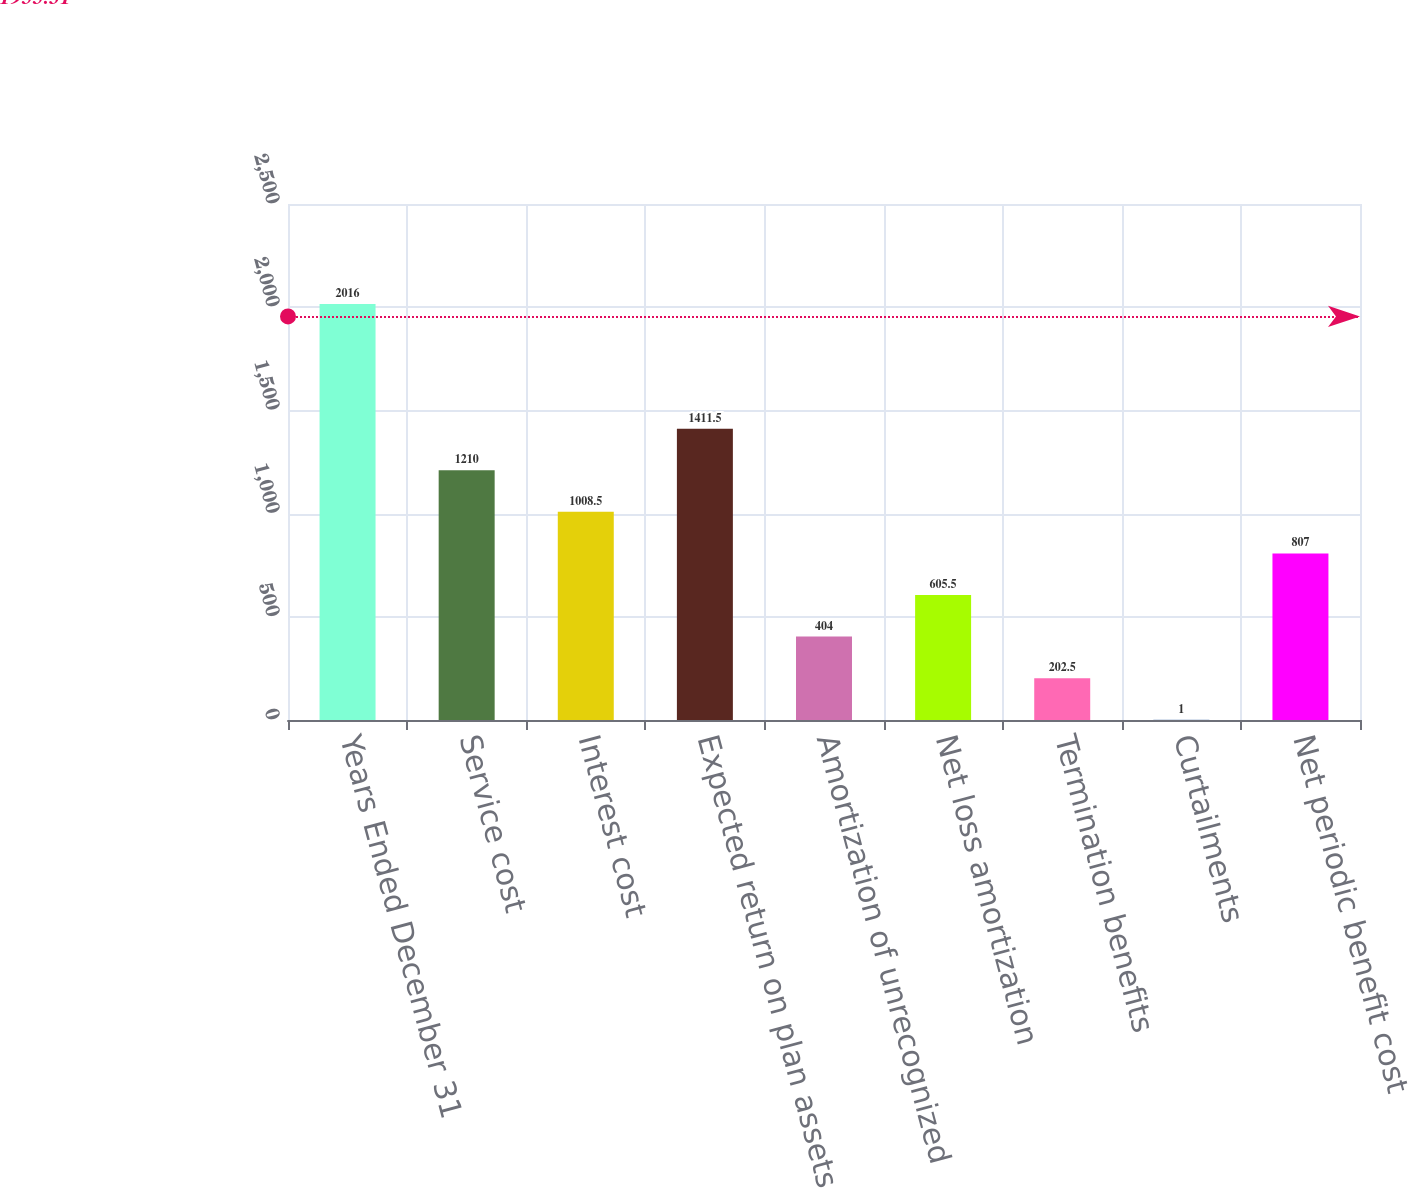<chart> <loc_0><loc_0><loc_500><loc_500><bar_chart><fcel>Years Ended December 31<fcel>Service cost<fcel>Interest cost<fcel>Expected return on plan assets<fcel>Amortization of unrecognized<fcel>Net loss amortization<fcel>Termination benefits<fcel>Curtailments<fcel>Net periodic benefit cost<nl><fcel>2016<fcel>1210<fcel>1008.5<fcel>1411.5<fcel>404<fcel>605.5<fcel>202.5<fcel>1<fcel>807<nl></chart> 